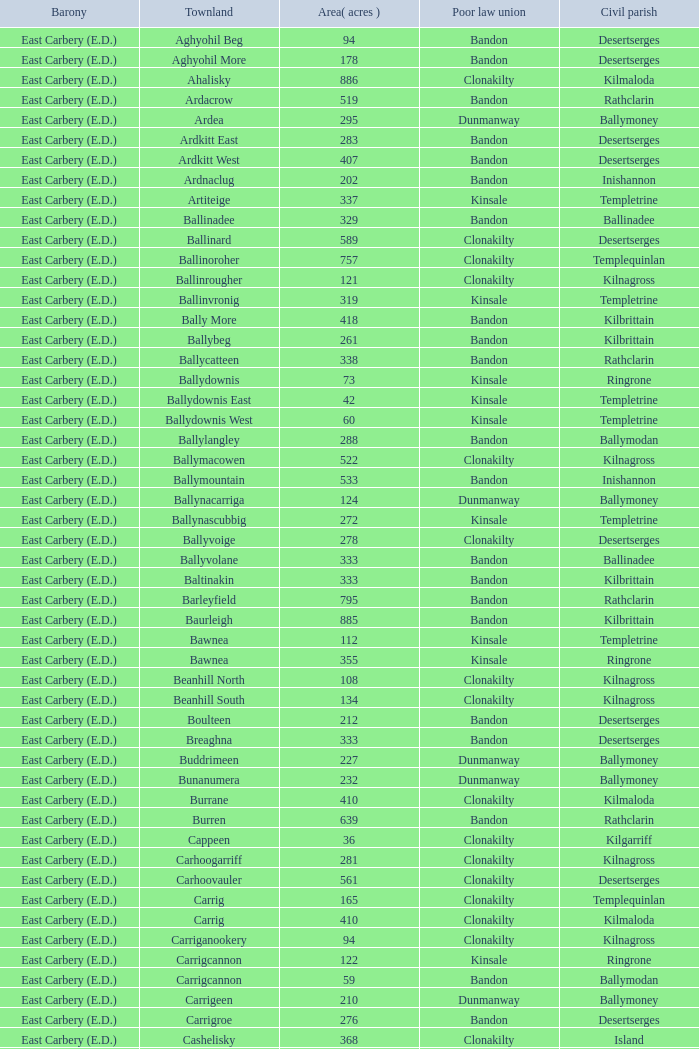What is the poor law union of the Ardacrow townland? Bandon. 